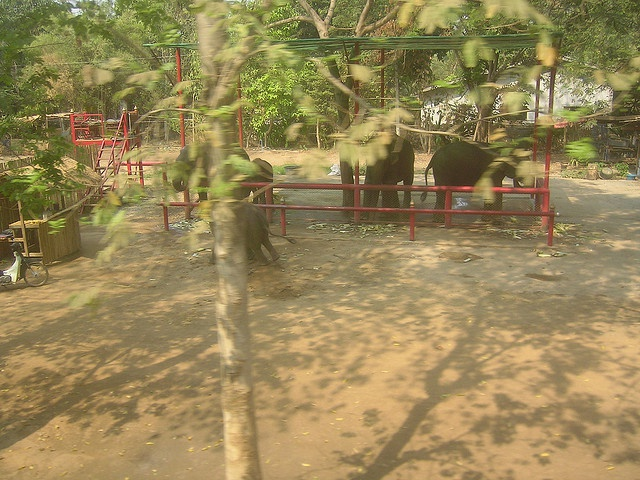Describe the objects in this image and their specific colors. I can see elephant in darkgray, olive, black, tan, and gray tones, elephant in darkgray, darkgreen, black, and tan tones, elephant in darkgray, olive, gray, and tan tones, motorcycle in darkgray, olive, and gray tones, and elephant in darkgray and olive tones in this image. 